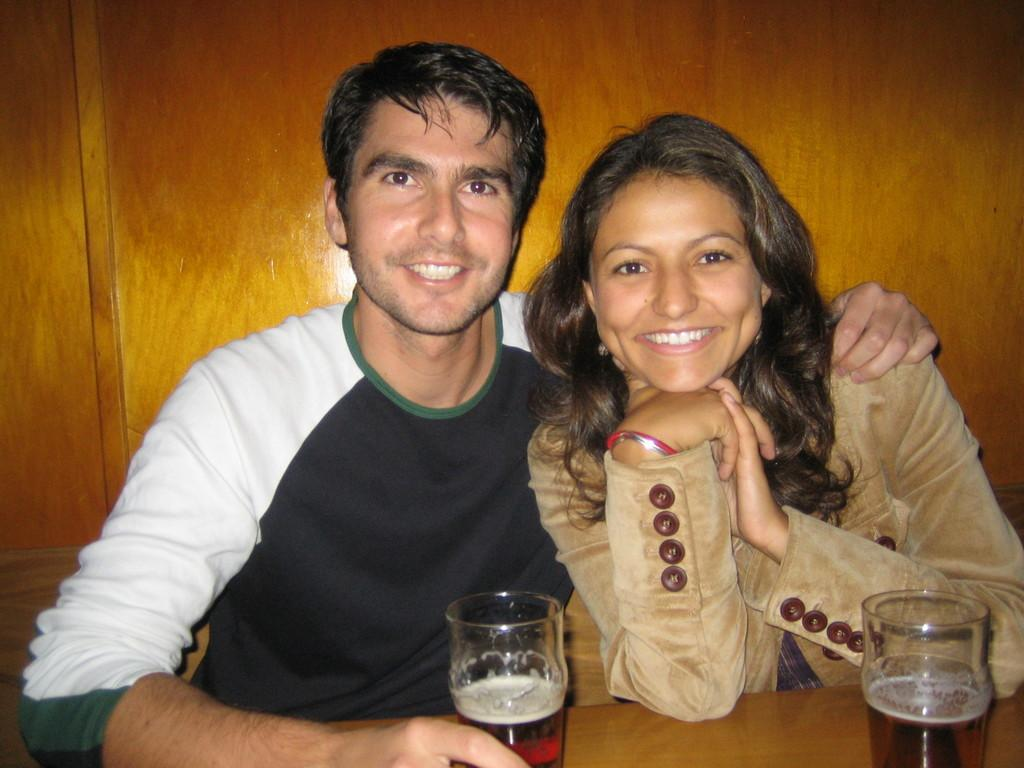How many people are present in the image? There are two people in the image. What are the people doing in the image? The image does not show them doing any specific activity, but they are sitting with drinks in front of them. What is the woman wearing in the image? The woman is wearing a brown coat. What is the man wearing in the image? The man is wearing a t-shirt. What can be seen in the background of the image? There is a wooden wall in the background of the image. What type of beam is holding up the rock in the image? There is no beam or rock present in the image. What type of voyage are the people embarking on in the image? The image does not show the people embarking on any voyage; they are simply sitting with drinks in front of them. 